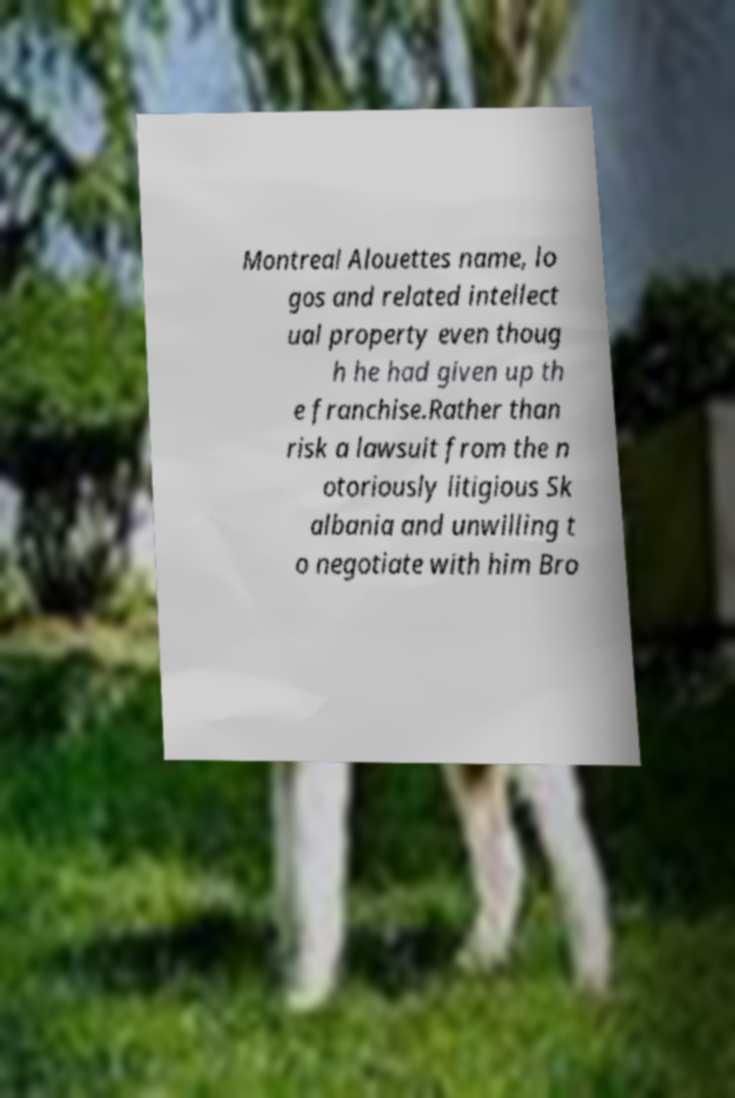Could you assist in decoding the text presented in this image and type it out clearly? Montreal Alouettes name, lo gos and related intellect ual property even thoug h he had given up th e franchise.Rather than risk a lawsuit from the n otoriously litigious Sk albania and unwilling t o negotiate with him Bro 